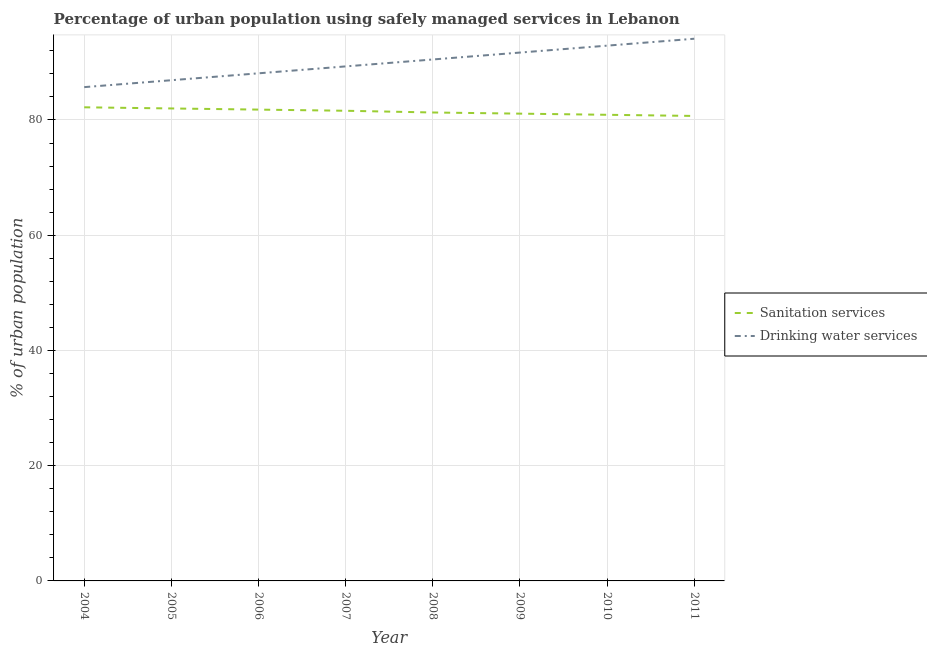Does the line corresponding to percentage of urban population who used drinking water services intersect with the line corresponding to percentage of urban population who used sanitation services?
Make the answer very short. No. What is the percentage of urban population who used drinking water services in 2008?
Keep it short and to the point. 90.5. Across all years, what is the maximum percentage of urban population who used drinking water services?
Give a very brief answer. 94.1. Across all years, what is the minimum percentage of urban population who used sanitation services?
Keep it short and to the point. 80.7. In which year was the percentage of urban population who used sanitation services maximum?
Provide a succinct answer. 2004. In which year was the percentage of urban population who used drinking water services minimum?
Provide a short and direct response. 2004. What is the total percentage of urban population who used drinking water services in the graph?
Provide a succinct answer. 719.2. What is the difference between the percentage of urban population who used drinking water services in 2008 and that in 2010?
Keep it short and to the point. -2.4. What is the difference between the percentage of urban population who used sanitation services in 2008 and the percentage of urban population who used drinking water services in 2005?
Make the answer very short. -5.6. What is the average percentage of urban population who used drinking water services per year?
Make the answer very short. 89.9. What is the ratio of the percentage of urban population who used sanitation services in 2006 to that in 2007?
Offer a very short reply. 1. Is the percentage of urban population who used sanitation services in 2004 less than that in 2006?
Make the answer very short. No. Is the difference between the percentage of urban population who used sanitation services in 2007 and 2008 greater than the difference between the percentage of urban population who used drinking water services in 2007 and 2008?
Make the answer very short. Yes. What is the difference between the highest and the second highest percentage of urban population who used drinking water services?
Make the answer very short. 1.2. What is the difference between the highest and the lowest percentage of urban population who used sanitation services?
Provide a succinct answer. 1.5. Does the percentage of urban population who used sanitation services monotonically increase over the years?
Provide a short and direct response. No. Is the percentage of urban population who used drinking water services strictly greater than the percentage of urban population who used sanitation services over the years?
Offer a very short reply. Yes. How many years are there in the graph?
Your answer should be very brief. 8. Does the graph contain grids?
Provide a succinct answer. Yes. Where does the legend appear in the graph?
Keep it short and to the point. Center right. How many legend labels are there?
Provide a short and direct response. 2. How are the legend labels stacked?
Your response must be concise. Vertical. What is the title of the graph?
Make the answer very short. Percentage of urban population using safely managed services in Lebanon. Does "Under five" appear as one of the legend labels in the graph?
Your response must be concise. No. What is the label or title of the Y-axis?
Provide a short and direct response. % of urban population. What is the % of urban population in Sanitation services in 2004?
Keep it short and to the point. 82.2. What is the % of urban population of Drinking water services in 2004?
Offer a terse response. 85.7. What is the % of urban population in Sanitation services in 2005?
Provide a short and direct response. 82. What is the % of urban population of Drinking water services in 2005?
Offer a terse response. 86.9. What is the % of urban population in Sanitation services in 2006?
Offer a very short reply. 81.8. What is the % of urban population of Drinking water services in 2006?
Provide a succinct answer. 88.1. What is the % of urban population of Sanitation services in 2007?
Ensure brevity in your answer.  81.6. What is the % of urban population of Drinking water services in 2007?
Make the answer very short. 89.3. What is the % of urban population of Sanitation services in 2008?
Ensure brevity in your answer.  81.3. What is the % of urban population in Drinking water services in 2008?
Your answer should be compact. 90.5. What is the % of urban population of Sanitation services in 2009?
Your response must be concise. 81.1. What is the % of urban population in Drinking water services in 2009?
Give a very brief answer. 91.7. What is the % of urban population in Sanitation services in 2010?
Your response must be concise. 80.9. What is the % of urban population in Drinking water services in 2010?
Provide a succinct answer. 92.9. What is the % of urban population in Sanitation services in 2011?
Your answer should be compact. 80.7. What is the % of urban population in Drinking water services in 2011?
Offer a terse response. 94.1. Across all years, what is the maximum % of urban population of Sanitation services?
Your answer should be very brief. 82.2. Across all years, what is the maximum % of urban population in Drinking water services?
Offer a terse response. 94.1. Across all years, what is the minimum % of urban population of Sanitation services?
Provide a short and direct response. 80.7. Across all years, what is the minimum % of urban population of Drinking water services?
Your response must be concise. 85.7. What is the total % of urban population in Sanitation services in the graph?
Your answer should be very brief. 651.6. What is the total % of urban population in Drinking water services in the graph?
Your answer should be very brief. 719.2. What is the difference between the % of urban population of Sanitation services in 2004 and that in 2006?
Make the answer very short. 0.4. What is the difference between the % of urban population in Drinking water services in 2004 and that in 2006?
Offer a very short reply. -2.4. What is the difference between the % of urban population in Drinking water services in 2004 and that in 2007?
Provide a succinct answer. -3.6. What is the difference between the % of urban population in Sanitation services in 2004 and that in 2009?
Your answer should be compact. 1.1. What is the difference between the % of urban population of Drinking water services in 2004 and that in 2009?
Keep it short and to the point. -6. What is the difference between the % of urban population of Sanitation services in 2004 and that in 2010?
Offer a terse response. 1.3. What is the difference between the % of urban population of Drinking water services in 2004 and that in 2010?
Keep it short and to the point. -7.2. What is the difference between the % of urban population of Sanitation services in 2005 and that in 2006?
Your answer should be compact. 0.2. What is the difference between the % of urban population of Sanitation services in 2005 and that in 2007?
Give a very brief answer. 0.4. What is the difference between the % of urban population in Sanitation services in 2005 and that in 2008?
Give a very brief answer. 0.7. What is the difference between the % of urban population of Drinking water services in 2005 and that in 2008?
Offer a very short reply. -3.6. What is the difference between the % of urban population of Sanitation services in 2005 and that in 2009?
Your answer should be compact. 0.9. What is the difference between the % of urban population of Sanitation services in 2005 and that in 2010?
Provide a succinct answer. 1.1. What is the difference between the % of urban population of Drinking water services in 2005 and that in 2010?
Provide a succinct answer. -6. What is the difference between the % of urban population of Sanitation services in 2005 and that in 2011?
Your answer should be very brief. 1.3. What is the difference between the % of urban population in Drinking water services in 2005 and that in 2011?
Keep it short and to the point. -7.2. What is the difference between the % of urban population of Sanitation services in 2006 and that in 2008?
Keep it short and to the point. 0.5. What is the difference between the % of urban population of Sanitation services in 2006 and that in 2009?
Provide a short and direct response. 0.7. What is the difference between the % of urban population in Sanitation services in 2006 and that in 2010?
Give a very brief answer. 0.9. What is the difference between the % of urban population in Drinking water services in 2006 and that in 2011?
Offer a terse response. -6. What is the difference between the % of urban population of Drinking water services in 2007 and that in 2008?
Your response must be concise. -1.2. What is the difference between the % of urban population of Drinking water services in 2007 and that in 2009?
Give a very brief answer. -2.4. What is the difference between the % of urban population of Drinking water services in 2007 and that in 2010?
Keep it short and to the point. -3.6. What is the difference between the % of urban population of Drinking water services in 2008 and that in 2009?
Make the answer very short. -1.2. What is the difference between the % of urban population in Sanitation services in 2008 and that in 2010?
Offer a very short reply. 0.4. What is the difference between the % of urban population in Sanitation services in 2008 and that in 2011?
Your answer should be very brief. 0.6. What is the difference between the % of urban population in Drinking water services in 2008 and that in 2011?
Offer a very short reply. -3.6. What is the difference between the % of urban population in Drinking water services in 2009 and that in 2010?
Your answer should be very brief. -1.2. What is the difference between the % of urban population in Sanitation services in 2009 and that in 2011?
Offer a very short reply. 0.4. What is the difference between the % of urban population in Drinking water services in 2009 and that in 2011?
Offer a very short reply. -2.4. What is the difference between the % of urban population of Sanitation services in 2004 and the % of urban population of Drinking water services in 2005?
Your answer should be compact. -4.7. What is the difference between the % of urban population in Sanitation services in 2004 and the % of urban population in Drinking water services in 2006?
Provide a succinct answer. -5.9. What is the difference between the % of urban population of Sanitation services in 2004 and the % of urban population of Drinking water services in 2007?
Give a very brief answer. -7.1. What is the difference between the % of urban population in Sanitation services in 2004 and the % of urban population in Drinking water services in 2010?
Offer a very short reply. -10.7. What is the difference between the % of urban population in Sanitation services in 2004 and the % of urban population in Drinking water services in 2011?
Ensure brevity in your answer.  -11.9. What is the difference between the % of urban population in Sanitation services in 2005 and the % of urban population in Drinking water services in 2006?
Give a very brief answer. -6.1. What is the difference between the % of urban population in Sanitation services in 2005 and the % of urban population in Drinking water services in 2009?
Ensure brevity in your answer.  -9.7. What is the difference between the % of urban population of Sanitation services in 2005 and the % of urban population of Drinking water services in 2010?
Your answer should be very brief. -10.9. What is the difference between the % of urban population in Sanitation services in 2006 and the % of urban population in Drinking water services in 2007?
Your answer should be very brief. -7.5. What is the difference between the % of urban population in Sanitation services in 2006 and the % of urban population in Drinking water services in 2008?
Make the answer very short. -8.7. What is the difference between the % of urban population in Sanitation services in 2006 and the % of urban population in Drinking water services in 2009?
Your answer should be very brief. -9.9. What is the difference between the % of urban population of Sanitation services in 2006 and the % of urban population of Drinking water services in 2010?
Provide a succinct answer. -11.1. What is the difference between the % of urban population of Sanitation services in 2006 and the % of urban population of Drinking water services in 2011?
Your answer should be very brief. -12.3. What is the difference between the % of urban population in Sanitation services in 2007 and the % of urban population in Drinking water services in 2011?
Provide a short and direct response. -12.5. What is the difference between the % of urban population in Sanitation services in 2008 and the % of urban population in Drinking water services in 2010?
Your answer should be compact. -11.6. What is the difference between the % of urban population of Sanitation services in 2008 and the % of urban population of Drinking water services in 2011?
Give a very brief answer. -12.8. What is the difference between the % of urban population in Sanitation services in 2009 and the % of urban population in Drinking water services in 2010?
Keep it short and to the point. -11.8. What is the difference between the % of urban population of Sanitation services in 2009 and the % of urban population of Drinking water services in 2011?
Ensure brevity in your answer.  -13. What is the average % of urban population in Sanitation services per year?
Offer a very short reply. 81.45. What is the average % of urban population in Drinking water services per year?
Offer a very short reply. 89.9. In the year 2004, what is the difference between the % of urban population of Sanitation services and % of urban population of Drinking water services?
Your response must be concise. -3.5. In the year 2005, what is the difference between the % of urban population in Sanitation services and % of urban population in Drinking water services?
Keep it short and to the point. -4.9. In the year 2006, what is the difference between the % of urban population in Sanitation services and % of urban population in Drinking water services?
Offer a very short reply. -6.3. In the year 2007, what is the difference between the % of urban population of Sanitation services and % of urban population of Drinking water services?
Keep it short and to the point. -7.7. In the year 2008, what is the difference between the % of urban population in Sanitation services and % of urban population in Drinking water services?
Make the answer very short. -9.2. What is the ratio of the % of urban population in Drinking water services in 2004 to that in 2005?
Ensure brevity in your answer.  0.99. What is the ratio of the % of urban population of Sanitation services in 2004 to that in 2006?
Your answer should be compact. 1. What is the ratio of the % of urban population of Drinking water services in 2004 to that in 2006?
Make the answer very short. 0.97. What is the ratio of the % of urban population in Sanitation services in 2004 to that in 2007?
Your answer should be very brief. 1.01. What is the ratio of the % of urban population in Drinking water services in 2004 to that in 2007?
Your answer should be compact. 0.96. What is the ratio of the % of urban population of Sanitation services in 2004 to that in 2008?
Provide a succinct answer. 1.01. What is the ratio of the % of urban population of Drinking water services in 2004 to that in 2008?
Keep it short and to the point. 0.95. What is the ratio of the % of urban population in Sanitation services in 2004 to that in 2009?
Your answer should be compact. 1.01. What is the ratio of the % of urban population in Drinking water services in 2004 to that in 2009?
Ensure brevity in your answer.  0.93. What is the ratio of the % of urban population of Sanitation services in 2004 to that in 2010?
Your answer should be compact. 1.02. What is the ratio of the % of urban population in Drinking water services in 2004 to that in 2010?
Your response must be concise. 0.92. What is the ratio of the % of urban population of Sanitation services in 2004 to that in 2011?
Offer a very short reply. 1.02. What is the ratio of the % of urban population of Drinking water services in 2004 to that in 2011?
Provide a short and direct response. 0.91. What is the ratio of the % of urban population of Drinking water services in 2005 to that in 2006?
Offer a very short reply. 0.99. What is the ratio of the % of urban population of Drinking water services in 2005 to that in 2007?
Your response must be concise. 0.97. What is the ratio of the % of urban population in Sanitation services in 2005 to that in 2008?
Ensure brevity in your answer.  1.01. What is the ratio of the % of urban population in Drinking water services in 2005 to that in 2008?
Your answer should be compact. 0.96. What is the ratio of the % of urban population of Sanitation services in 2005 to that in 2009?
Your answer should be very brief. 1.01. What is the ratio of the % of urban population of Drinking water services in 2005 to that in 2009?
Give a very brief answer. 0.95. What is the ratio of the % of urban population in Sanitation services in 2005 to that in 2010?
Keep it short and to the point. 1.01. What is the ratio of the % of urban population in Drinking water services in 2005 to that in 2010?
Provide a short and direct response. 0.94. What is the ratio of the % of urban population of Sanitation services in 2005 to that in 2011?
Give a very brief answer. 1.02. What is the ratio of the % of urban population in Drinking water services in 2005 to that in 2011?
Offer a terse response. 0.92. What is the ratio of the % of urban population of Sanitation services in 2006 to that in 2007?
Keep it short and to the point. 1. What is the ratio of the % of urban population in Drinking water services in 2006 to that in 2007?
Keep it short and to the point. 0.99. What is the ratio of the % of urban population in Sanitation services in 2006 to that in 2008?
Keep it short and to the point. 1.01. What is the ratio of the % of urban population of Drinking water services in 2006 to that in 2008?
Give a very brief answer. 0.97. What is the ratio of the % of urban population of Sanitation services in 2006 to that in 2009?
Offer a very short reply. 1.01. What is the ratio of the % of urban population of Drinking water services in 2006 to that in 2009?
Give a very brief answer. 0.96. What is the ratio of the % of urban population of Sanitation services in 2006 to that in 2010?
Ensure brevity in your answer.  1.01. What is the ratio of the % of urban population in Drinking water services in 2006 to that in 2010?
Provide a succinct answer. 0.95. What is the ratio of the % of urban population in Sanitation services in 2006 to that in 2011?
Make the answer very short. 1.01. What is the ratio of the % of urban population in Drinking water services in 2006 to that in 2011?
Provide a short and direct response. 0.94. What is the ratio of the % of urban population of Drinking water services in 2007 to that in 2008?
Keep it short and to the point. 0.99. What is the ratio of the % of urban population of Drinking water services in 2007 to that in 2009?
Keep it short and to the point. 0.97. What is the ratio of the % of urban population in Sanitation services in 2007 to that in 2010?
Provide a short and direct response. 1.01. What is the ratio of the % of urban population in Drinking water services in 2007 to that in 2010?
Provide a succinct answer. 0.96. What is the ratio of the % of urban population in Sanitation services in 2007 to that in 2011?
Offer a terse response. 1.01. What is the ratio of the % of urban population in Drinking water services in 2007 to that in 2011?
Your answer should be compact. 0.95. What is the ratio of the % of urban population in Drinking water services in 2008 to that in 2009?
Provide a short and direct response. 0.99. What is the ratio of the % of urban population in Sanitation services in 2008 to that in 2010?
Keep it short and to the point. 1. What is the ratio of the % of urban population in Drinking water services in 2008 to that in 2010?
Offer a very short reply. 0.97. What is the ratio of the % of urban population of Sanitation services in 2008 to that in 2011?
Provide a short and direct response. 1.01. What is the ratio of the % of urban population in Drinking water services in 2008 to that in 2011?
Your answer should be very brief. 0.96. What is the ratio of the % of urban population of Sanitation services in 2009 to that in 2010?
Give a very brief answer. 1. What is the ratio of the % of urban population in Drinking water services in 2009 to that in 2010?
Your answer should be compact. 0.99. What is the ratio of the % of urban population of Drinking water services in 2009 to that in 2011?
Provide a succinct answer. 0.97. What is the ratio of the % of urban population in Drinking water services in 2010 to that in 2011?
Ensure brevity in your answer.  0.99. What is the difference between the highest and the lowest % of urban population in Sanitation services?
Your answer should be very brief. 1.5. What is the difference between the highest and the lowest % of urban population in Drinking water services?
Your answer should be compact. 8.4. 